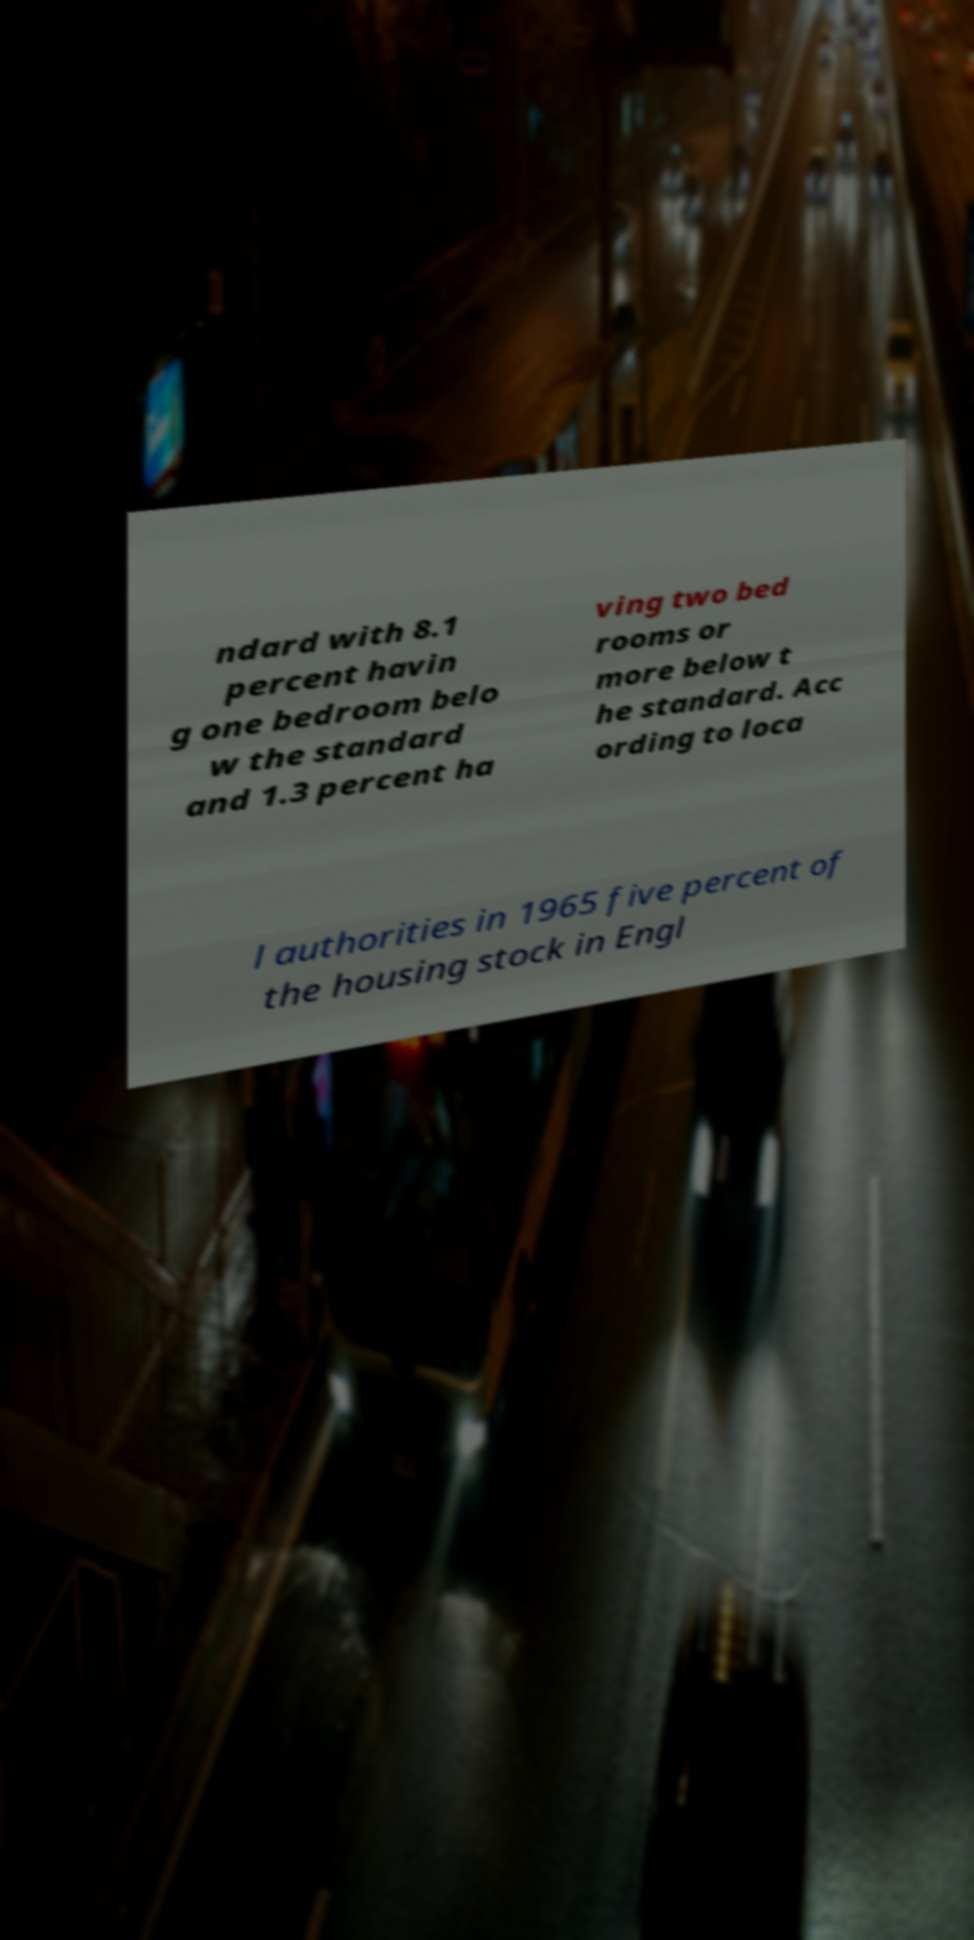Can you read and provide the text displayed in the image?This photo seems to have some interesting text. Can you extract and type it out for me? ndard with 8.1 percent havin g one bedroom belo w the standard and 1.3 percent ha ving two bed rooms or more below t he standard. Acc ording to loca l authorities in 1965 five percent of the housing stock in Engl 